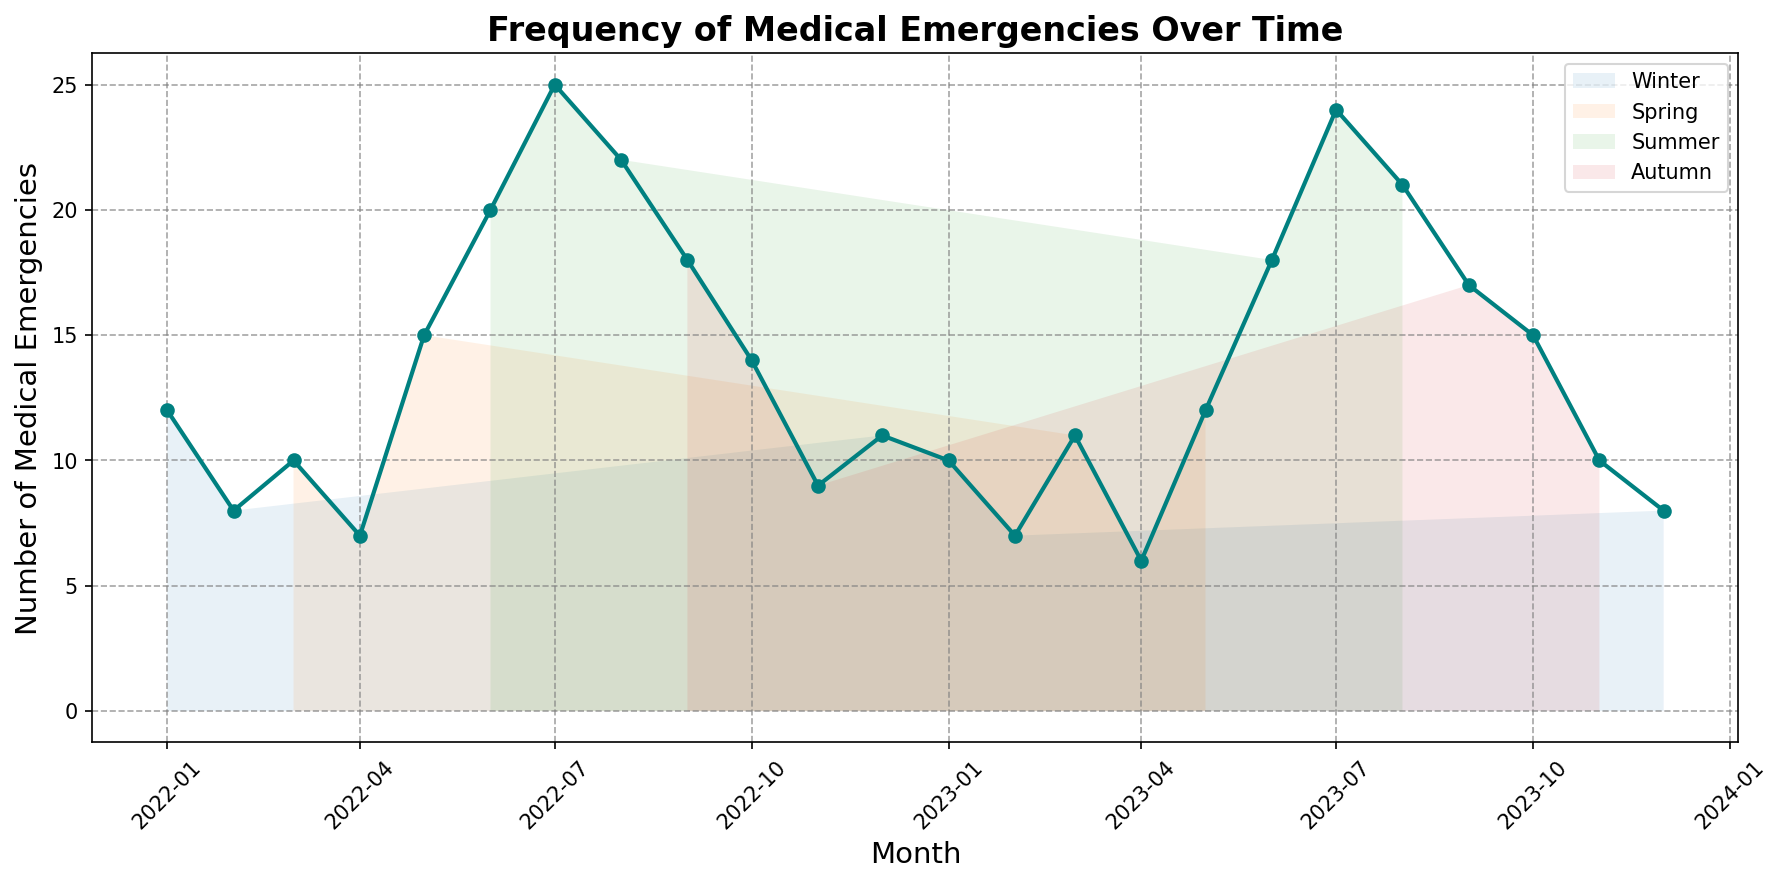What is the month with the highest number of medical emergencies? By observing the peaks in the line chart, the month with the highest spike will indicate the highest number of medical emergencies. This seems to occur in July 2022 with 25 emergencies.
Answer: July 2022 Which season has the highest overall trend in medical emergencies? Consider the overall line height within each seasonal section: Winter (Dec, Jan, Feb), Spring (Mar, Apr, May), Summer (Jun, Jul, Aug), and Autumn (Sep, Oct, Nov). Summer generally has the consistently highest line values compared to other seasons.
Answer: Summer How does the number of medical emergencies in May 2022 compare to May 2023? Look at the line chart points for May 2022 and May 2023, and compare their heights. May 2022 has 15 emergencies, while May 2023 has 12. Hence, May 2022 has more than May 2023.
Answer: May 2022 has more What is the average number of medical emergencies in 2022? Add the number of monthly emergencies for 2022 (12+8+10+7+15+20+25+22+18+14+9+11) and divide by 12. The total is 171, so the average is 171/12 = 14.25 emergencies per month.
Answer: 14.25 Which month saw a decrease in medical emergencies from December 2022 to January 2023? Check the values for December 2022 and January 2023. December 2022 has 11 emergencies, and January 2023 has 10, indicating a decrease.
Answer: January 2023 What is the overall trend in medical emergencies from June to August over the two years? Examine June, July, and August in both 2022 and 2023. Both years show an increase from June (20 in 2022 and 18 in 2023) to July (25 in 2022 and 24 in 2023), then a slight drop to August (22 in 2022 and 21 in 2023). Overall, the trend is an initial rise followed by a slight drop.
Answer: Rise then slight drop Which quarter shows a significant drop in medical emergencies in 2023 compared to the previous quarter? Divide the year into quarters and compare each. The second quarter (April-June) of 2023 shows a drop compared to the first quarter (January-March). Q1 has (10+7+11) = 28; Q2 has (6+12+18) = 36, showing an increase in Q2. Thus, the drop is from Q2 to Q3 where Q3 has (24+21+17) = 62, making Q2 to Q3 still an increase. A further drop is not apparent until refering November-December drop.
Answer: None What visual attribute helps separate seasonal trends in the chart? The chart uses light-colored backgrounds under the line to differentiate seasonal zones, such as Spring, Summer, Autumn, and Winter, making it easier to distinguish between these periods.
Answer: Seasonal backgrounds How many times do medical emergencies exceed 20 in 2023? Identify the months in 2023 where the line reaches above 20 emergencies. The months are June (18, less), July (24), and August (21). There are two instances.
Answer: 2 times 